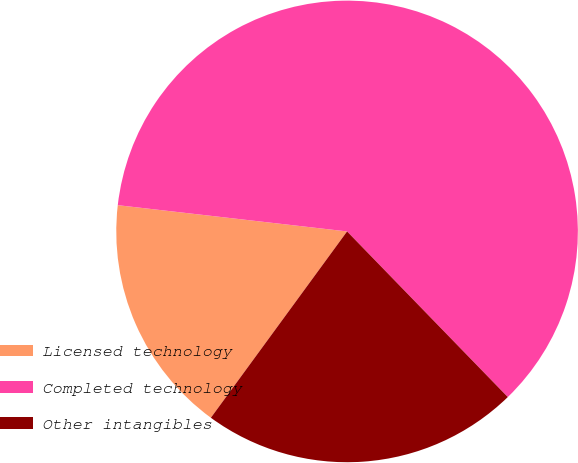Convert chart. <chart><loc_0><loc_0><loc_500><loc_500><pie_chart><fcel>Licensed technology<fcel>Completed technology<fcel>Other intangibles<nl><fcel>16.77%<fcel>60.93%<fcel>22.31%<nl></chart> 